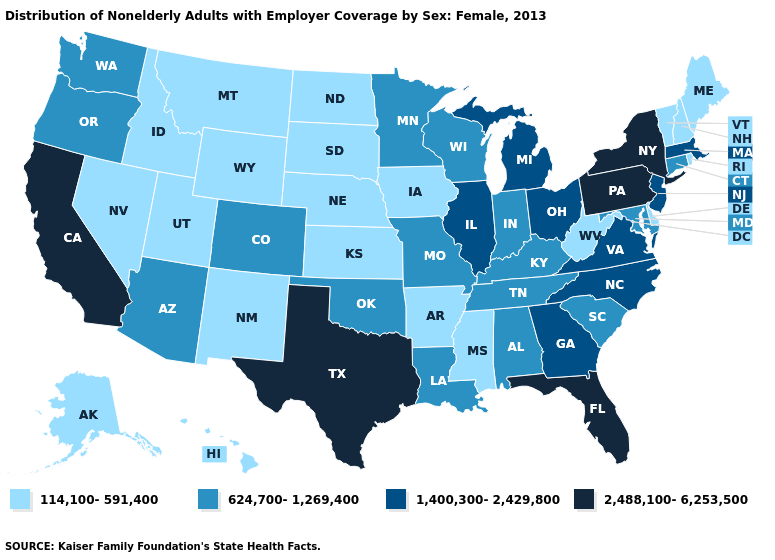Which states have the lowest value in the USA?
Keep it brief. Alaska, Arkansas, Delaware, Hawaii, Idaho, Iowa, Kansas, Maine, Mississippi, Montana, Nebraska, Nevada, New Hampshire, New Mexico, North Dakota, Rhode Island, South Dakota, Utah, Vermont, West Virginia, Wyoming. Does Ohio have the same value as Virginia?
Write a very short answer. Yes. Among the states that border Washington , which have the lowest value?
Short answer required. Idaho. What is the value of Hawaii?
Concise answer only. 114,100-591,400. Which states hav the highest value in the West?
Quick response, please. California. What is the value of South Carolina?
Quick response, please. 624,700-1,269,400. How many symbols are there in the legend?
Answer briefly. 4. What is the value of South Dakota?
Concise answer only. 114,100-591,400. Which states hav the highest value in the Northeast?
Concise answer only. New York, Pennsylvania. What is the value of Tennessee?
Be succinct. 624,700-1,269,400. Does the map have missing data?
Keep it brief. No. Among the states that border Missouri , which have the lowest value?
Keep it brief. Arkansas, Iowa, Kansas, Nebraska. Which states hav the highest value in the West?
Give a very brief answer. California. What is the lowest value in states that border Connecticut?
Be succinct. 114,100-591,400. What is the highest value in the Northeast ?
Answer briefly. 2,488,100-6,253,500. 